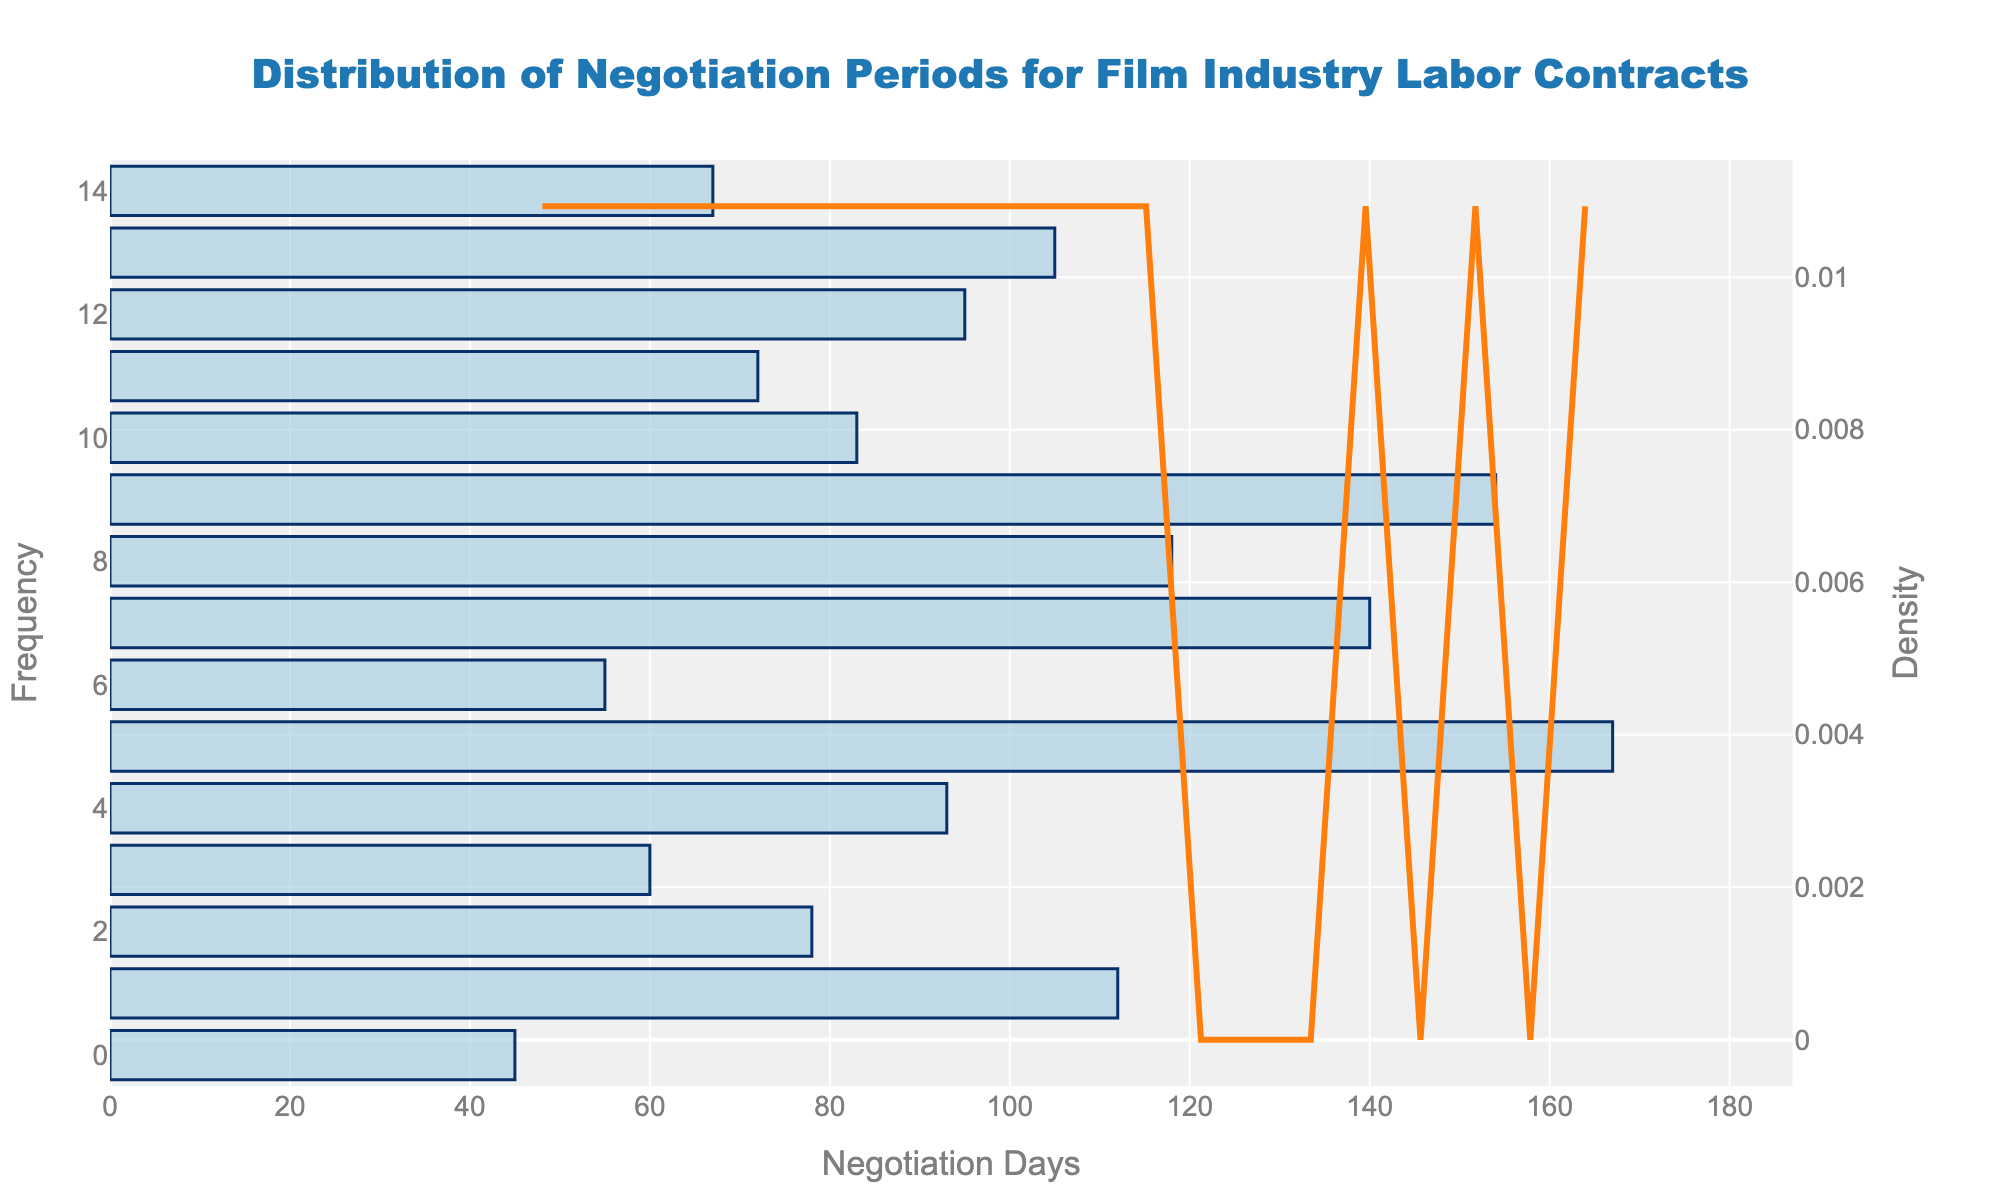What's the title of the figure? The figure's title is located at the top and is printed prominently in a large font size. By directly reading it, you can identify the title.
Answer: Distribution of Negotiation Periods for Film Industry Labor Contracts What is displayed along the x-axis? The x-axis label is usually found close to the bottom of the figure, providing a description of what the axis represents.
Answer: Negotiation Days What is the x-axis range in the figure? The x-axis shows the range of values, starting from 0 up to a little beyond the maximum negotiation days, plus some buffer. By looking at the axis, you can see the range.
Answer: 0 to around 180 How many labor contracts are represented in the data? Each bar in the histogram represents a separate contract. By counting the bars, you can find the number of labor contracts.
Answer: 15 What does each bar in the histogram represent? Each bar in the histogram represents a certain frequency of negotiation days for labor contracts. This is typical in a histogram where each bar's height indicates how many data points fall within a certain range.
Answer: Frequency of negotiation days What general trend do you see in negotiation periods over time? The KDE (density curve) smooths out the data, showing a general trend. By observing the shape of this curve, you can note if there are peaks or troughs that indicate common negotiation periods.
Answer: Most negotiation periods cluster around shorter durations with a long tail to the right What is the purpose of the KDE line in the plot? The KDE line provides a smoothed estimate of the distribution of negotiation days, helping to visualize the general trend amid the raw data represented by the histogram.
Answer: To show the smoothed distribution of negotiation days Is there a negotiation period that stands out as particularly frequent in the histogram? By comparing the heights of the bars in the histogram, you can determine if any specific period has a notably higher frequency than others.
Answer: Yes, one shorter period stands out Between the earliest and latest negotiation periods, which one had a longer duration? Identify the earliest and latest contracts from the data, then compare their negotiation days as shown on the x-axis.
Answer: The latest negotiation period (2023) is longer How do the majority of negotiation periods compare to the KDE peak? Locate the peak of the KDE curve and compare it to the frequency distribution in the histogram to understand where the majority of the negotiation periods lie.
Answer: They mostly lie around the KDE peak at shorter durations Which negotiation period had the highest frequency in the histogram? The highest bar represents the period with the greatest frequency; observe the bar heights directly to determine this.
Answer: The period around 55-60 days 